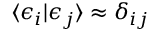<formula> <loc_0><loc_0><loc_500><loc_500>\langle \epsilon _ { i } | \epsilon _ { j } \rangle \approx \delta _ { i j }</formula> 